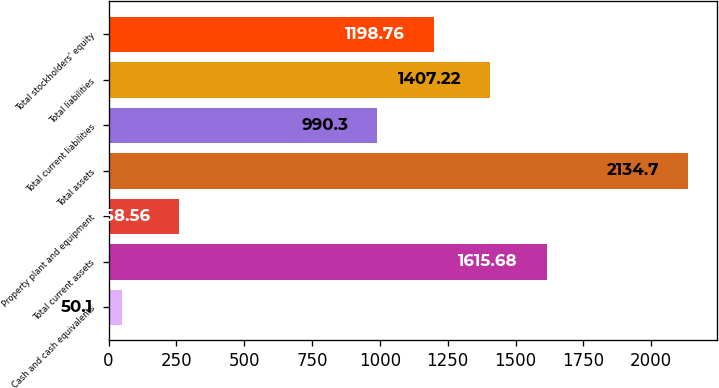Convert chart to OTSL. <chart><loc_0><loc_0><loc_500><loc_500><bar_chart><fcel>Cash and cash equivalents<fcel>Total current assets<fcel>Property plant and equipment<fcel>Total assets<fcel>Total current liabilities<fcel>Total liabilities<fcel>Total stockholders' equity<nl><fcel>50.1<fcel>1615.68<fcel>258.56<fcel>2134.7<fcel>990.3<fcel>1407.22<fcel>1198.76<nl></chart> 